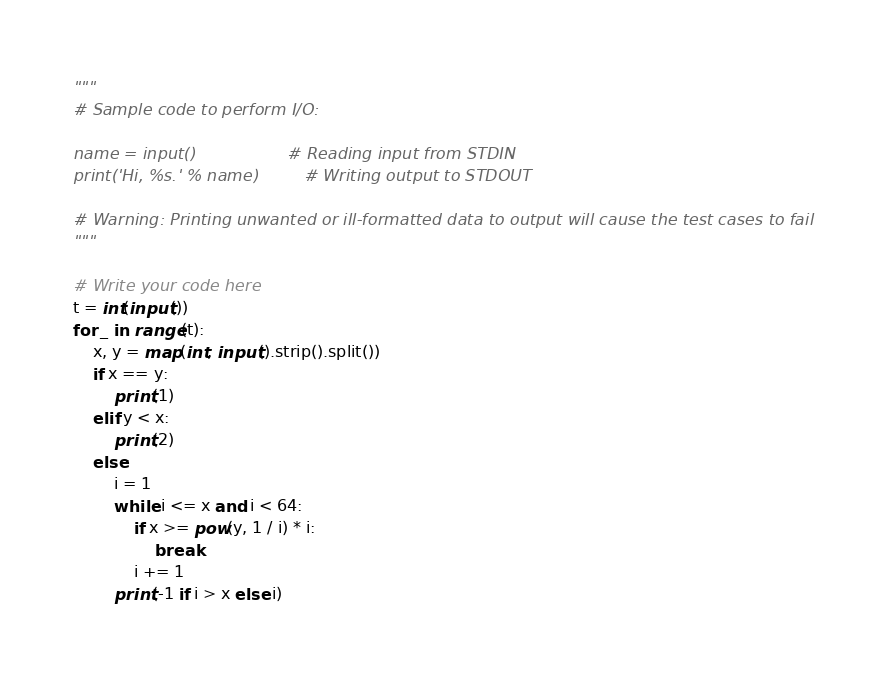<code> <loc_0><loc_0><loc_500><loc_500><_Python_>"""
# Sample code to perform I/O:

name = input()                  # Reading input from STDIN
print('Hi, %s.' % name)         # Writing output to STDOUT

# Warning: Printing unwanted or ill-formatted data to output will cause the test cases to fail
"""

# Write your code here
t = int(input())
for _ in range(t):
    x, y = map(int, input().strip().split())
    if x == y:
        print(1)
    elif y < x:
        print(2)
    else:
        i = 1
        while i <= x and i < 64:
            if x >= pow(y, 1 / i) * i:
                break
            i += 1
        print(-1 if i > x else i)
</code> 